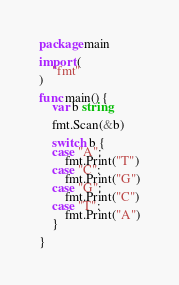<code> <loc_0><loc_0><loc_500><loc_500><_Go_>package main

import (
	"fmt"
)

func main() {
	var b string

	fmt.Scan(&b)

	switch b {
	case "A":
		fmt.Print("T")
	case "C":
		fmt.Print("G")
	case "G":
		fmt.Print("C")
	case "T":
		fmt.Print("A")
	}

}
</code> 